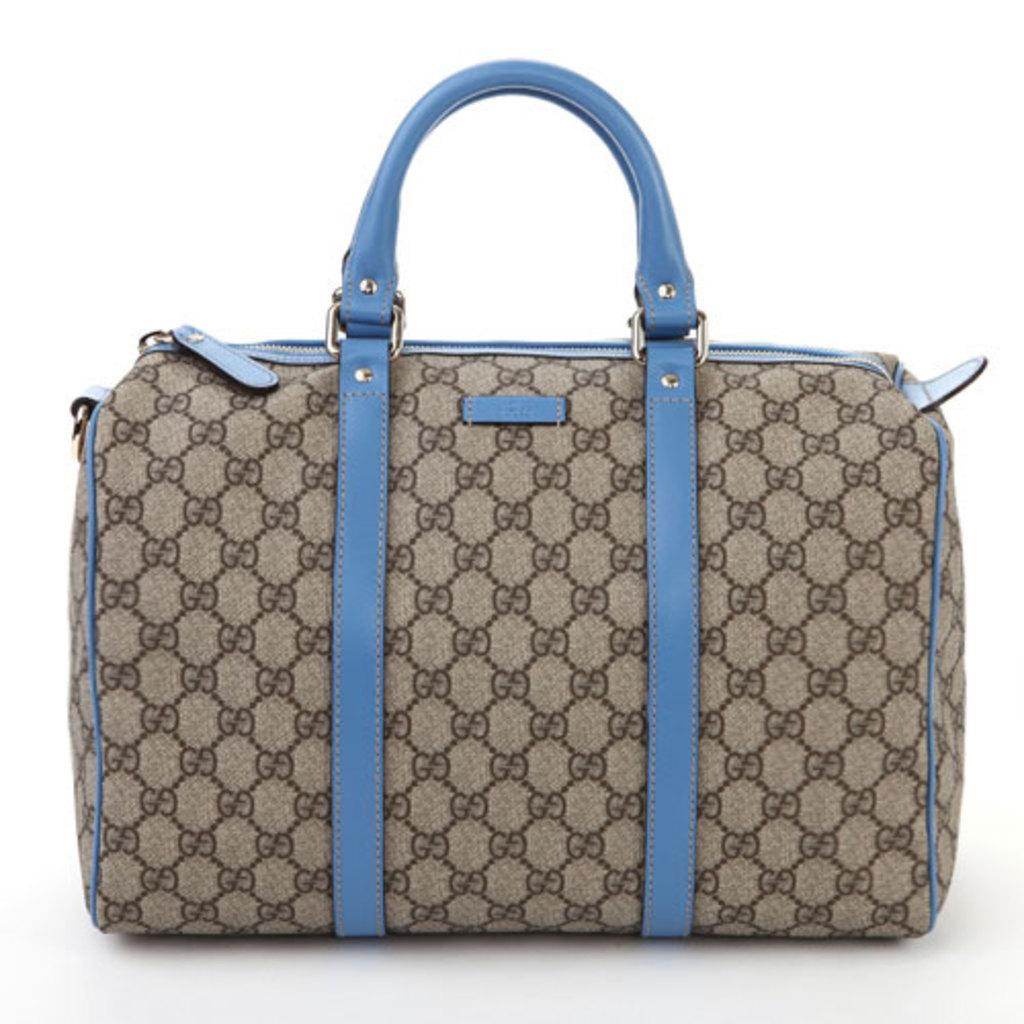What type of accessory is present in the image? There is a handbag in the picture. What is the color of the handbag? The handbag is brown in color. Are there any other colors present on the handbag? Yes, the handle and belt of the handbag are blue in color. What type of cream is being applied to the handbag in the image? There is no cream being applied to the handbag in the image. What action is the handbag performing in the image? The handbag is an inanimate object and cannot perform actions. 